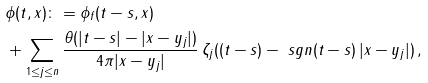<formula> <loc_0><loc_0><loc_500><loc_500>& \phi ( t , x ) \colon = \phi _ { f } ( t - s , x ) \\ & + \sum _ { 1 \leq j \leq n } \frac { \theta ( | t - s | - | x - y _ { j } | ) } { 4 \pi | x - y _ { j } | } \, \zeta _ { j } ( ( t - s ) - \ s g n ( t - s ) \, | x - y _ { j } | ) \, ,</formula> 